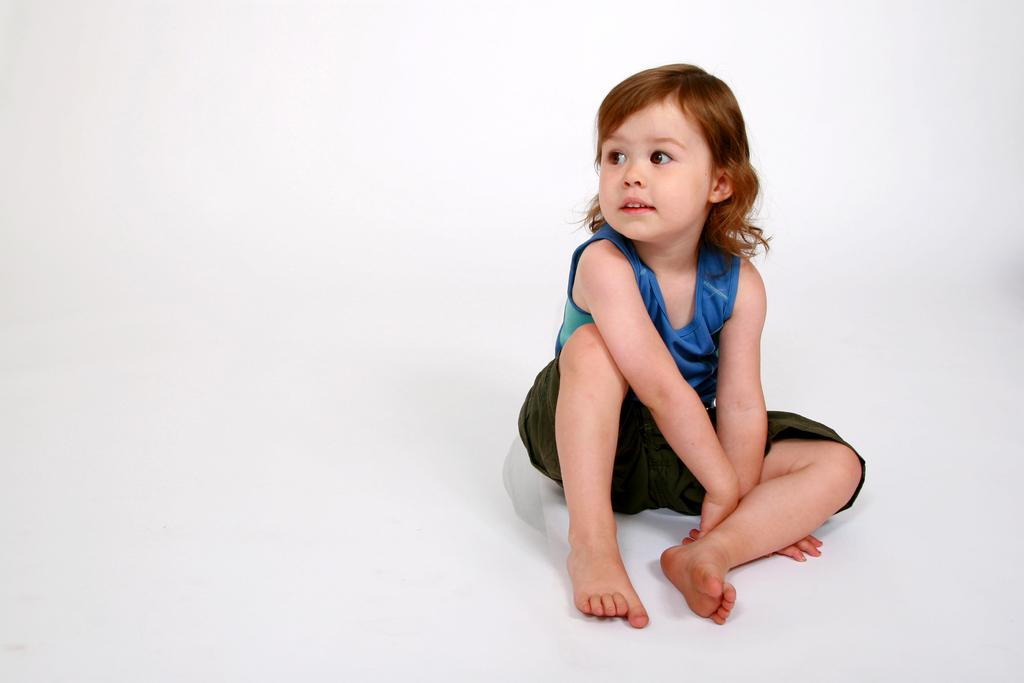Who is the main subject in the picture? There is a girl in the picture. What is the girl wearing? The girl is wearing a blue t-shirt and black shorts. What is the girl's position in the picture? The girl is sitting on the floor. What type of industry is depicted in the background of the picture? There is no industry present in the image; it only features a girl sitting on the floor. 